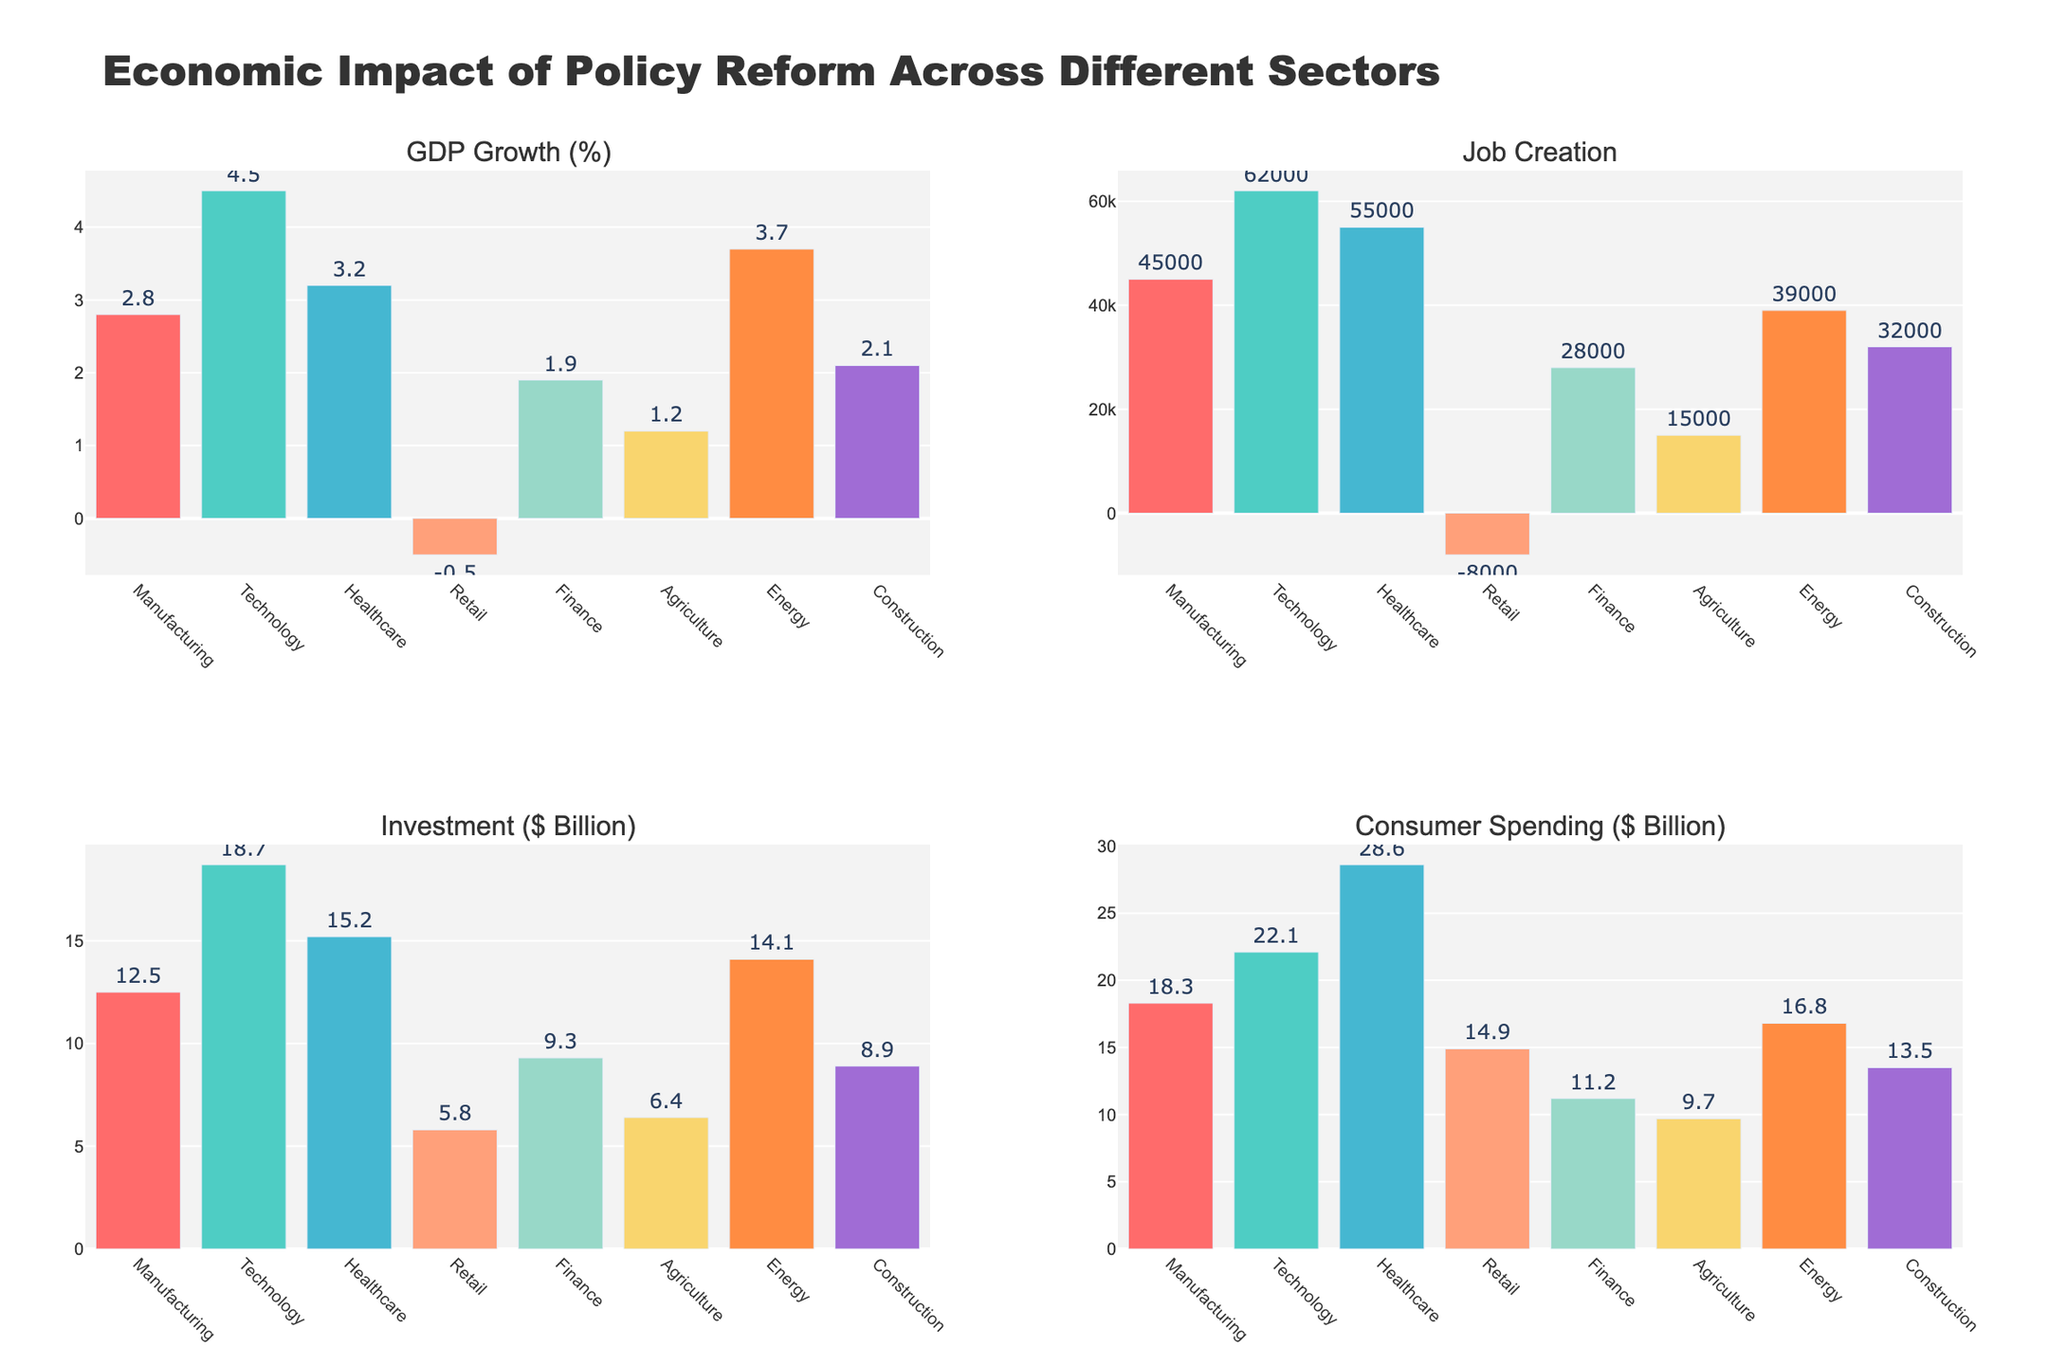What is the title of the figure? The title of the figure is displayed at the top center and reads "Economic Impact of Policy Reform Across Different Sectors".
Answer: Economic Impact of Policy Reform Across Different Sectors Which sector shows the highest percentage growth in GDP? From the subplot titled 'GDP Growth (%)', the sector with the highest bar is "Technology", indicating it has the highest percentage growth.
Answer: Technology How much is the total job creation across all sectors combined? To find the total job creation, sum the job creation values across all sectors: 45000 + 62000 + 55000 + (-8000) + 28000 + 15000 + 39000 + 32000 = 284000.
Answer: 284000 Which sector has the lowest consumer spending, and what is that amount? From the subplot titled 'Consumer Spending ($ Billion)', the shortest bar belongs to "Agriculture", with a value of 9.7 billion dollars.
Answer: Agriculture, 9.7 Compare the investment in the Technology and Finance sectors. Which one is higher, and by how much? Looking at the subplot titled 'Investment ($ Billion)', Technology has 18.7 billion dollars, and Finance has 9.3 billion dollars. The difference is 18.7 - 9.3 = 9.4 billion dollars.
Answer: Technology, 9.4 billion dollars What is the average GDP growth (%) of all sectors combined? Sum the GDP growth percentages of all sectors: 2.8 + 4.5 + 3.2 + (-0.5) + 1.9 + 1.2 + 3.7 + 2.1 = 18.9. Then divide by the number of sectors which is 8. The average is 18.9 / 8 = 2.3625%.
Answer: 2.36% How many sectors experienced negative job creation? From the subplot titled 'Job Creation', look for sectors with negative values. Only "Retail" has a negative job creation of -8000.
Answer: 1 Which sector has the highest investment, and how much is it? The highest bar in the 'Investment ($ Billion)' subplot belongs to "Technology", with an investment of 18.7 billion dollars.
Answer: Technology, 18.7 billion dollars Is there any sector where GDP growth and job creation are both negative? Check 'GDP Growth (%)' and 'Job Creation' subplots. Retail is the only sector with negative values in both, with -0.5% GDP growth and -8000 job creation.
Answer: Retail What is the difference in consumer spending between Healthcare and Retail sectors? From the 'Consumer Spending ($ Billion)' subplot, Healthcare has 28.6 billion dollars and Retail has 14.9 billion dollars. The difference is 28.6 - 14.9 = 13.7 billion dollars.
Answer: 13.7 billion dollars 